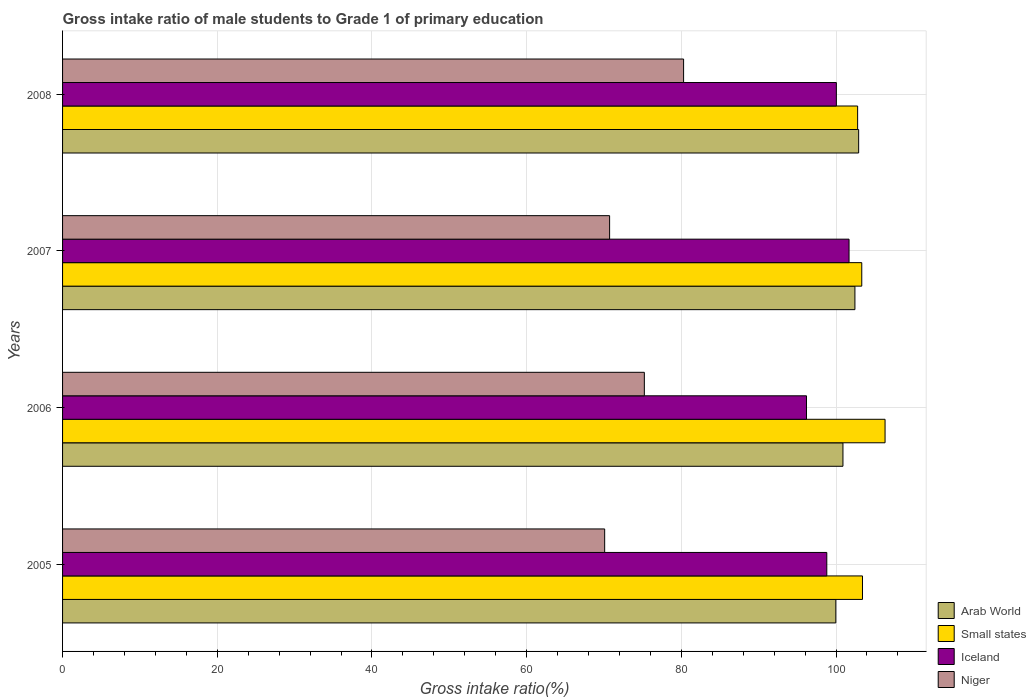How many different coloured bars are there?
Your answer should be compact. 4. Are the number of bars on each tick of the Y-axis equal?
Make the answer very short. Yes. In how many cases, is the number of bars for a given year not equal to the number of legend labels?
Your answer should be compact. 0. What is the gross intake ratio in Niger in 2008?
Make the answer very short. 80.29. Across all years, what is the maximum gross intake ratio in Arab World?
Your answer should be very brief. 102.93. Across all years, what is the minimum gross intake ratio in Small states?
Your response must be concise. 102.8. In which year was the gross intake ratio in Iceland maximum?
Offer a terse response. 2007. What is the total gross intake ratio in Iceland in the graph?
Your answer should be compact. 396.73. What is the difference between the gross intake ratio in Small states in 2005 and that in 2008?
Ensure brevity in your answer.  0.63. What is the difference between the gross intake ratio in Niger in 2008 and the gross intake ratio in Iceland in 2007?
Provide a short and direct response. -21.39. What is the average gross intake ratio in Small states per year?
Offer a very short reply. 103.97. In the year 2005, what is the difference between the gross intake ratio in Niger and gross intake ratio in Small states?
Your answer should be very brief. -33.33. What is the ratio of the gross intake ratio in Small states in 2005 to that in 2007?
Give a very brief answer. 1. Is the gross intake ratio in Small states in 2006 less than that in 2007?
Make the answer very short. No. What is the difference between the highest and the second highest gross intake ratio in Arab World?
Give a very brief answer. 0.48. What is the difference between the highest and the lowest gross intake ratio in Niger?
Provide a short and direct response. 10.2. In how many years, is the gross intake ratio in Niger greater than the average gross intake ratio in Niger taken over all years?
Ensure brevity in your answer.  2. Is it the case that in every year, the sum of the gross intake ratio in Arab World and gross intake ratio in Niger is greater than the sum of gross intake ratio in Iceland and gross intake ratio in Small states?
Make the answer very short. No. What does the 2nd bar from the top in 2005 represents?
Give a very brief answer. Iceland. What does the 3rd bar from the bottom in 2005 represents?
Offer a very short reply. Iceland. How many bars are there?
Your answer should be compact. 16. Are all the bars in the graph horizontal?
Ensure brevity in your answer.  Yes. How many years are there in the graph?
Provide a short and direct response. 4. What is the difference between two consecutive major ticks on the X-axis?
Provide a short and direct response. 20. Does the graph contain any zero values?
Your answer should be very brief. No. Does the graph contain grids?
Keep it short and to the point. Yes. Where does the legend appear in the graph?
Provide a succinct answer. Bottom right. How are the legend labels stacked?
Provide a short and direct response. Vertical. What is the title of the graph?
Offer a terse response. Gross intake ratio of male students to Grade 1 of primary education. Does "Arab World" appear as one of the legend labels in the graph?
Offer a terse response. Yes. What is the label or title of the X-axis?
Your response must be concise. Gross intake ratio(%). What is the label or title of the Y-axis?
Offer a very short reply. Years. What is the Gross intake ratio(%) of Arab World in 2005?
Your answer should be very brief. 99.98. What is the Gross intake ratio(%) in Small states in 2005?
Offer a very short reply. 103.42. What is the Gross intake ratio(%) in Iceland in 2005?
Keep it short and to the point. 98.81. What is the Gross intake ratio(%) of Niger in 2005?
Provide a succinct answer. 70.09. What is the Gross intake ratio(%) in Arab World in 2006?
Offer a terse response. 100.9. What is the Gross intake ratio(%) in Small states in 2006?
Your answer should be very brief. 106.35. What is the Gross intake ratio(%) in Iceland in 2006?
Offer a very short reply. 96.19. What is the Gross intake ratio(%) of Niger in 2006?
Give a very brief answer. 75.22. What is the Gross intake ratio(%) of Arab World in 2007?
Provide a short and direct response. 102.45. What is the Gross intake ratio(%) of Small states in 2007?
Provide a succinct answer. 103.33. What is the Gross intake ratio(%) in Iceland in 2007?
Give a very brief answer. 101.69. What is the Gross intake ratio(%) in Niger in 2007?
Make the answer very short. 70.73. What is the Gross intake ratio(%) in Arab World in 2008?
Provide a succinct answer. 102.93. What is the Gross intake ratio(%) in Small states in 2008?
Offer a very short reply. 102.8. What is the Gross intake ratio(%) of Iceland in 2008?
Offer a terse response. 100.05. What is the Gross intake ratio(%) of Niger in 2008?
Provide a succinct answer. 80.29. Across all years, what is the maximum Gross intake ratio(%) in Arab World?
Keep it short and to the point. 102.93. Across all years, what is the maximum Gross intake ratio(%) in Small states?
Provide a short and direct response. 106.35. Across all years, what is the maximum Gross intake ratio(%) of Iceland?
Your answer should be compact. 101.69. Across all years, what is the maximum Gross intake ratio(%) in Niger?
Keep it short and to the point. 80.29. Across all years, what is the minimum Gross intake ratio(%) of Arab World?
Your answer should be very brief. 99.98. Across all years, what is the minimum Gross intake ratio(%) in Small states?
Offer a terse response. 102.8. Across all years, what is the minimum Gross intake ratio(%) of Iceland?
Your response must be concise. 96.19. Across all years, what is the minimum Gross intake ratio(%) of Niger?
Your answer should be compact. 70.09. What is the total Gross intake ratio(%) of Arab World in the graph?
Your answer should be compact. 406.26. What is the total Gross intake ratio(%) in Small states in the graph?
Make the answer very short. 415.9. What is the total Gross intake ratio(%) in Iceland in the graph?
Keep it short and to the point. 396.73. What is the total Gross intake ratio(%) in Niger in the graph?
Give a very brief answer. 296.34. What is the difference between the Gross intake ratio(%) in Arab World in 2005 and that in 2006?
Provide a short and direct response. -0.92. What is the difference between the Gross intake ratio(%) of Small states in 2005 and that in 2006?
Keep it short and to the point. -2.92. What is the difference between the Gross intake ratio(%) of Iceland in 2005 and that in 2006?
Your response must be concise. 2.62. What is the difference between the Gross intake ratio(%) in Niger in 2005 and that in 2006?
Provide a short and direct response. -5.13. What is the difference between the Gross intake ratio(%) of Arab World in 2005 and that in 2007?
Keep it short and to the point. -2.47. What is the difference between the Gross intake ratio(%) in Small states in 2005 and that in 2007?
Give a very brief answer. 0.09. What is the difference between the Gross intake ratio(%) in Iceland in 2005 and that in 2007?
Make the answer very short. -2.88. What is the difference between the Gross intake ratio(%) in Niger in 2005 and that in 2007?
Offer a very short reply. -0.64. What is the difference between the Gross intake ratio(%) of Arab World in 2005 and that in 2008?
Make the answer very short. -2.95. What is the difference between the Gross intake ratio(%) of Small states in 2005 and that in 2008?
Offer a very short reply. 0.63. What is the difference between the Gross intake ratio(%) in Iceland in 2005 and that in 2008?
Make the answer very short. -1.24. What is the difference between the Gross intake ratio(%) of Niger in 2005 and that in 2008?
Your answer should be compact. -10.2. What is the difference between the Gross intake ratio(%) of Arab World in 2006 and that in 2007?
Provide a succinct answer. -1.55. What is the difference between the Gross intake ratio(%) of Small states in 2006 and that in 2007?
Your answer should be compact. 3.01. What is the difference between the Gross intake ratio(%) in Iceland in 2006 and that in 2007?
Give a very brief answer. -5.5. What is the difference between the Gross intake ratio(%) of Niger in 2006 and that in 2007?
Ensure brevity in your answer.  4.49. What is the difference between the Gross intake ratio(%) in Arab World in 2006 and that in 2008?
Make the answer very short. -2.03. What is the difference between the Gross intake ratio(%) in Small states in 2006 and that in 2008?
Make the answer very short. 3.55. What is the difference between the Gross intake ratio(%) in Iceland in 2006 and that in 2008?
Give a very brief answer. -3.86. What is the difference between the Gross intake ratio(%) of Niger in 2006 and that in 2008?
Give a very brief answer. -5.07. What is the difference between the Gross intake ratio(%) in Arab World in 2007 and that in 2008?
Offer a very short reply. -0.48. What is the difference between the Gross intake ratio(%) of Small states in 2007 and that in 2008?
Offer a very short reply. 0.53. What is the difference between the Gross intake ratio(%) in Iceland in 2007 and that in 2008?
Ensure brevity in your answer.  1.64. What is the difference between the Gross intake ratio(%) of Niger in 2007 and that in 2008?
Offer a very short reply. -9.56. What is the difference between the Gross intake ratio(%) of Arab World in 2005 and the Gross intake ratio(%) of Small states in 2006?
Ensure brevity in your answer.  -6.37. What is the difference between the Gross intake ratio(%) in Arab World in 2005 and the Gross intake ratio(%) in Iceland in 2006?
Make the answer very short. 3.79. What is the difference between the Gross intake ratio(%) in Arab World in 2005 and the Gross intake ratio(%) in Niger in 2006?
Your answer should be very brief. 24.76. What is the difference between the Gross intake ratio(%) in Small states in 2005 and the Gross intake ratio(%) in Iceland in 2006?
Your answer should be compact. 7.24. What is the difference between the Gross intake ratio(%) of Small states in 2005 and the Gross intake ratio(%) of Niger in 2006?
Give a very brief answer. 28.2. What is the difference between the Gross intake ratio(%) of Iceland in 2005 and the Gross intake ratio(%) of Niger in 2006?
Make the answer very short. 23.59. What is the difference between the Gross intake ratio(%) in Arab World in 2005 and the Gross intake ratio(%) in Small states in 2007?
Offer a very short reply. -3.35. What is the difference between the Gross intake ratio(%) of Arab World in 2005 and the Gross intake ratio(%) of Iceland in 2007?
Make the answer very short. -1.71. What is the difference between the Gross intake ratio(%) of Arab World in 2005 and the Gross intake ratio(%) of Niger in 2007?
Provide a succinct answer. 29.25. What is the difference between the Gross intake ratio(%) of Small states in 2005 and the Gross intake ratio(%) of Iceland in 2007?
Provide a succinct answer. 1.74. What is the difference between the Gross intake ratio(%) in Small states in 2005 and the Gross intake ratio(%) in Niger in 2007?
Offer a terse response. 32.69. What is the difference between the Gross intake ratio(%) of Iceland in 2005 and the Gross intake ratio(%) of Niger in 2007?
Ensure brevity in your answer.  28.08. What is the difference between the Gross intake ratio(%) of Arab World in 2005 and the Gross intake ratio(%) of Small states in 2008?
Keep it short and to the point. -2.82. What is the difference between the Gross intake ratio(%) of Arab World in 2005 and the Gross intake ratio(%) of Iceland in 2008?
Provide a succinct answer. -0.07. What is the difference between the Gross intake ratio(%) in Arab World in 2005 and the Gross intake ratio(%) in Niger in 2008?
Your response must be concise. 19.68. What is the difference between the Gross intake ratio(%) of Small states in 2005 and the Gross intake ratio(%) of Iceland in 2008?
Provide a short and direct response. 3.38. What is the difference between the Gross intake ratio(%) in Small states in 2005 and the Gross intake ratio(%) in Niger in 2008?
Give a very brief answer. 23.13. What is the difference between the Gross intake ratio(%) of Iceland in 2005 and the Gross intake ratio(%) of Niger in 2008?
Offer a terse response. 18.52. What is the difference between the Gross intake ratio(%) in Arab World in 2006 and the Gross intake ratio(%) in Small states in 2007?
Offer a terse response. -2.43. What is the difference between the Gross intake ratio(%) of Arab World in 2006 and the Gross intake ratio(%) of Iceland in 2007?
Your answer should be very brief. -0.79. What is the difference between the Gross intake ratio(%) of Arab World in 2006 and the Gross intake ratio(%) of Niger in 2007?
Offer a very short reply. 30.17. What is the difference between the Gross intake ratio(%) of Small states in 2006 and the Gross intake ratio(%) of Iceland in 2007?
Ensure brevity in your answer.  4.66. What is the difference between the Gross intake ratio(%) in Small states in 2006 and the Gross intake ratio(%) in Niger in 2007?
Your answer should be compact. 35.62. What is the difference between the Gross intake ratio(%) in Iceland in 2006 and the Gross intake ratio(%) in Niger in 2007?
Your response must be concise. 25.46. What is the difference between the Gross intake ratio(%) in Arab World in 2006 and the Gross intake ratio(%) in Small states in 2008?
Provide a succinct answer. -1.9. What is the difference between the Gross intake ratio(%) in Arab World in 2006 and the Gross intake ratio(%) in Iceland in 2008?
Keep it short and to the point. 0.85. What is the difference between the Gross intake ratio(%) of Arab World in 2006 and the Gross intake ratio(%) of Niger in 2008?
Provide a short and direct response. 20.61. What is the difference between the Gross intake ratio(%) in Small states in 2006 and the Gross intake ratio(%) in Iceland in 2008?
Keep it short and to the point. 6.3. What is the difference between the Gross intake ratio(%) of Small states in 2006 and the Gross intake ratio(%) of Niger in 2008?
Your response must be concise. 26.05. What is the difference between the Gross intake ratio(%) in Iceland in 2006 and the Gross intake ratio(%) in Niger in 2008?
Give a very brief answer. 15.89. What is the difference between the Gross intake ratio(%) in Arab World in 2007 and the Gross intake ratio(%) in Small states in 2008?
Give a very brief answer. -0.35. What is the difference between the Gross intake ratio(%) of Arab World in 2007 and the Gross intake ratio(%) of Iceland in 2008?
Your answer should be very brief. 2.4. What is the difference between the Gross intake ratio(%) of Arab World in 2007 and the Gross intake ratio(%) of Niger in 2008?
Give a very brief answer. 22.15. What is the difference between the Gross intake ratio(%) in Small states in 2007 and the Gross intake ratio(%) in Iceland in 2008?
Provide a succinct answer. 3.28. What is the difference between the Gross intake ratio(%) in Small states in 2007 and the Gross intake ratio(%) in Niger in 2008?
Offer a very short reply. 23.04. What is the difference between the Gross intake ratio(%) of Iceland in 2007 and the Gross intake ratio(%) of Niger in 2008?
Ensure brevity in your answer.  21.39. What is the average Gross intake ratio(%) of Arab World per year?
Make the answer very short. 101.56. What is the average Gross intake ratio(%) of Small states per year?
Ensure brevity in your answer.  103.97. What is the average Gross intake ratio(%) in Iceland per year?
Give a very brief answer. 99.18. What is the average Gross intake ratio(%) of Niger per year?
Ensure brevity in your answer.  74.08. In the year 2005, what is the difference between the Gross intake ratio(%) in Arab World and Gross intake ratio(%) in Small states?
Keep it short and to the point. -3.45. In the year 2005, what is the difference between the Gross intake ratio(%) of Arab World and Gross intake ratio(%) of Iceland?
Make the answer very short. 1.17. In the year 2005, what is the difference between the Gross intake ratio(%) of Arab World and Gross intake ratio(%) of Niger?
Keep it short and to the point. 29.89. In the year 2005, what is the difference between the Gross intake ratio(%) in Small states and Gross intake ratio(%) in Iceland?
Offer a very short reply. 4.61. In the year 2005, what is the difference between the Gross intake ratio(%) of Small states and Gross intake ratio(%) of Niger?
Your answer should be very brief. 33.33. In the year 2005, what is the difference between the Gross intake ratio(%) of Iceland and Gross intake ratio(%) of Niger?
Provide a succinct answer. 28.72. In the year 2006, what is the difference between the Gross intake ratio(%) in Arab World and Gross intake ratio(%) in Small states?
Make the answer very short. -5.44. In the year 2006, what is the difference between the Gross intake ratio(%) of Arab World and Gross intake ratio(%) of Iceland?
Give a very brief answer. 4.71. In the year 2006, what is the difference between the Gross intake ratio(%) in Arab World and Gross intake ratio(%) in Niger?
Ensure brevity in your answer.  25.68. In the year 2006, what is the difference between the Gross intake ratio(%) of Small states and Gross intake ratio(%) of Iceland?
Make the answer very short. 10.16. In the year 2006, what is the difference between the Gross intake ratio(%) in Small states and Gross intake ratio(%) in Niger?
Make the answer very short. 31.12. In the year 2006, what is the difference between the Gross intake ratio(%) in Iceland and Gross intake ratio(%) in Niger?
Provide a short and direct response. 20.96. In the year 2007, what is the difference between the Gross intake ratio(%) of Arab World and Gross intake ratio(%) of Small states?
Your answer should be compact. -0.88. In the year 2007, what is the difference between the Gross intake ratio(%) of Arab World and Gross intake ratio(%) of Iceland?
Provide a short and direct response. 0.76. In the year 2007, what is the difference between the Gross intake ratio(%) in Arab World and Gross intake ratio(%) in Niger?
Make the answer very short. 31.72. In the year 2007, what is the difference between the Gross intake ratio(%) in Small states and Gross intake ratio(%) in Iceland?
Provide a short and direct response. 1.64. In the year 2007, what is the difference between the Gross intake ratio(%) in Small states and Gross intake ratio(%) in Niger?
Your response must be concise. 32.6. In the year 2007, what is the difference between the Gross intake ratio(%) of Iceland and Gross intake ratio(%) of Niger?
Your response must be concise. 30.96. In the year 2008, what is the difference between the Gross intake ratio(%) in Arab World and Gross intake ratio(%) in Small states?
Ensure brevity in your answer.  0.13. In the year 2008, what is the difference between the Gross intake ratio(%) of Arab World and Gross intake ratio(%) of Iceland?
Offer a terse response. 2.88. In the year 2008, what is the difference between the Gross intake ratio(%) in Arab World and Gross intake ratio(%) in Niger?
Your response must be concise. 22.64. In the year 2008, what is the difference between the Gross intake ratio(%) of Small states and Gross intake ratio(%) of Iceland?
Ensure brevity in your answer.  2.75. In the year 2008, what is the difference between the Gross intake ratio(%) in Small states and Gross intake ratio(%) in Niger?
Provide a short and direct response. 22.5. In the year 2008, what is the difference between the Gross intake ratio(%) in Iceland and Gross intake ratio(%) in Niger?
Keep it short and to the point. 19.75. What is the ratio of the Gross intake ratio(%) in Arab World in 2005 to that in 2006?
Provide a short and direct response. 0.99. What is the ratio of the Gross intake ratio(%) in Small states in 2005 to that in 2006?
Make the answer very short. 0.97. What is the ratio of the Gross intake ratio(%) of Iceland in 2005 to that in 2006?
Your answer should be very brief. 1.03. What is the ratio of the Gross intake ratio(%) in Niger in 2005 to that in 2006?
Your response must be concise. 0.93. What is the ratio of the Gross intake ratio(%) in Arab World in 2005 to that in 2007?
Offer a terse response. 0.98. What is the ratio of the Gross intake ratio(%) in Small states in 2005 to that in 2007?
Offer a very short reply. 1. What is the ratio of the Gross intake ratio(%) of Iceland in 2005 to that in 2007?
Give a very brief answer. 0.97. What is the ratio of the Gross intake ratio(%) of Niger in 2005 to that in 2007?
Your answer should be very brief. 0.99. What is the ratio of the Gross intake ratio(%) of Arab World in 2005 to that in 2008?
Your answer should be very brief. 0.97. What is the ratio of the Gross intake ratio(%) in Iceland in 2005 to that in 2008?
Your response must be concise. 0.99. What is the ratio of the Gross intake ratio(%) in Niger in 2005 to that in 2008?
Provide a short and direct response. 0.87. What is the ratio of the Gross intake ratio(%) in Arab World in 2006 to that in 2007?
Provide a short and direct response. 0.98. What is the ratio of the Gross intake ratio(%) in Small states in 2006 to that in 2007?
Offer a very short reply. 1.03. What is the ratio of the Gross intake ratio(%) of Iceland in 2006 to that in 2007?
Your answer should be very brief. 0.95. What is the ratio of the Gross intake ratio(%) in Niger in 2006 to that in 2007?
Your answer should be very brief. 1.06. What is the ratio of the Gross intake ratio(%) in Arab World in 2006 to that in 2008?
Your answer should be compact. 0.98. What is the ratio of the Gross intake ratio(%) in Small states in 2006 to that in 2008?
Your response must be concise. 1.03. What is the ratio of the Gross intake ratio(%) of Iceland in 2006 to that in 2008?
Your answer should be very brief. 0.96. What is the ratio of the Gross intake ratio(%) in Niger in 2006 to that in 2008?
Your response must be concise. 0.94. What is the ratio of the Gross intake ratio(%) in Iceland in 2007 to that in 2008?
Give a very brief answer. 1.02. What is the ratio of the Gross intake ratio(%) in Niger in 2007 to that in 2008?
Your answer should be very brief. 0.88. What is the difference between the highest and the second highest Gross intake ratio(%) of Arab World?
Give a very brief answer. 0.48. What is the difference between the highest and the second highest Gross intake ratio(%) of Small states?
Offer a terse response. 2.92. What is the difference between the highest and the second highest Gross intake ratio(%) of Iceland?
Provide a succinct answer. 1.64. What is the difference between the highest and the second highest Gross intake ratio(%) of Niger?
Give a very brief answer. 5.07. What is the difference between the highest and the lowest Gross intake ratio(%) of Arab World?
Give a very brief answer. 2.95. What is the difference between the highest and the lowest Gross intake ratio(%) of Small states?
Your answer should be very brief. 3.55. What is the difference between the highest and the lowest Gross intake ratio(%) in Iceland?
Provide a short and direct response. 5.5. What is the difference between the highest and the lowest Gross intake ratio(%) of Niger?
Your answer should be compact. 10.2. 